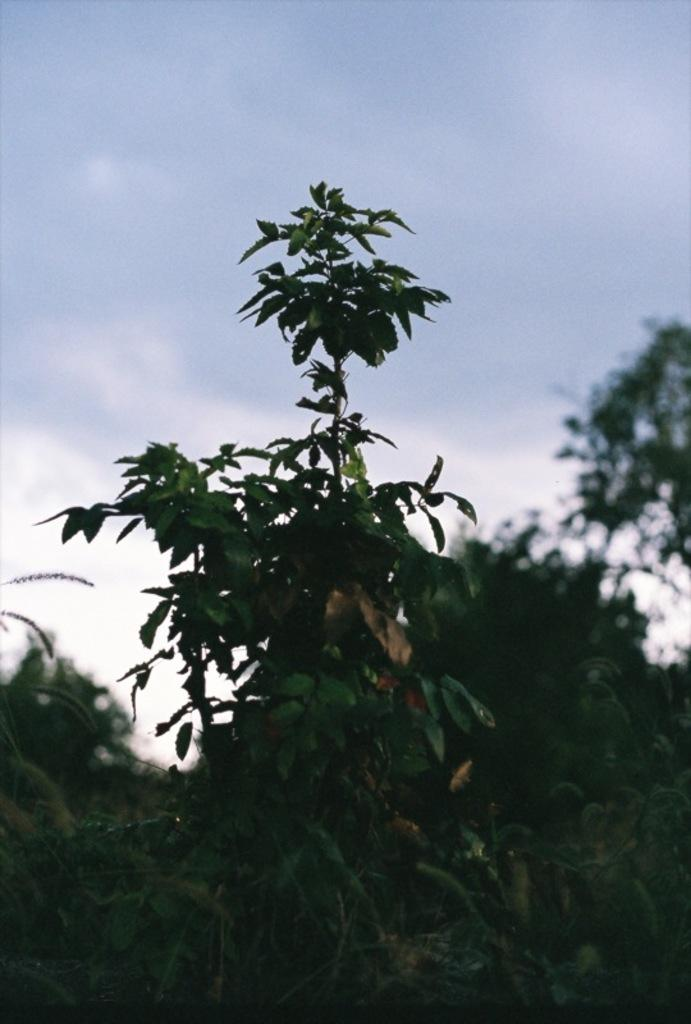What is the main subject in the middle of the image? There is a tree with green leaves in the middle of the image. What can be seen in the background of the image? There are trees in the background of the image. What is visible in the sky in the image? There are clouds in the sky. What type of machine is being used to create the rainstorm in the image? There is no rainstorm or machine present in the image. 